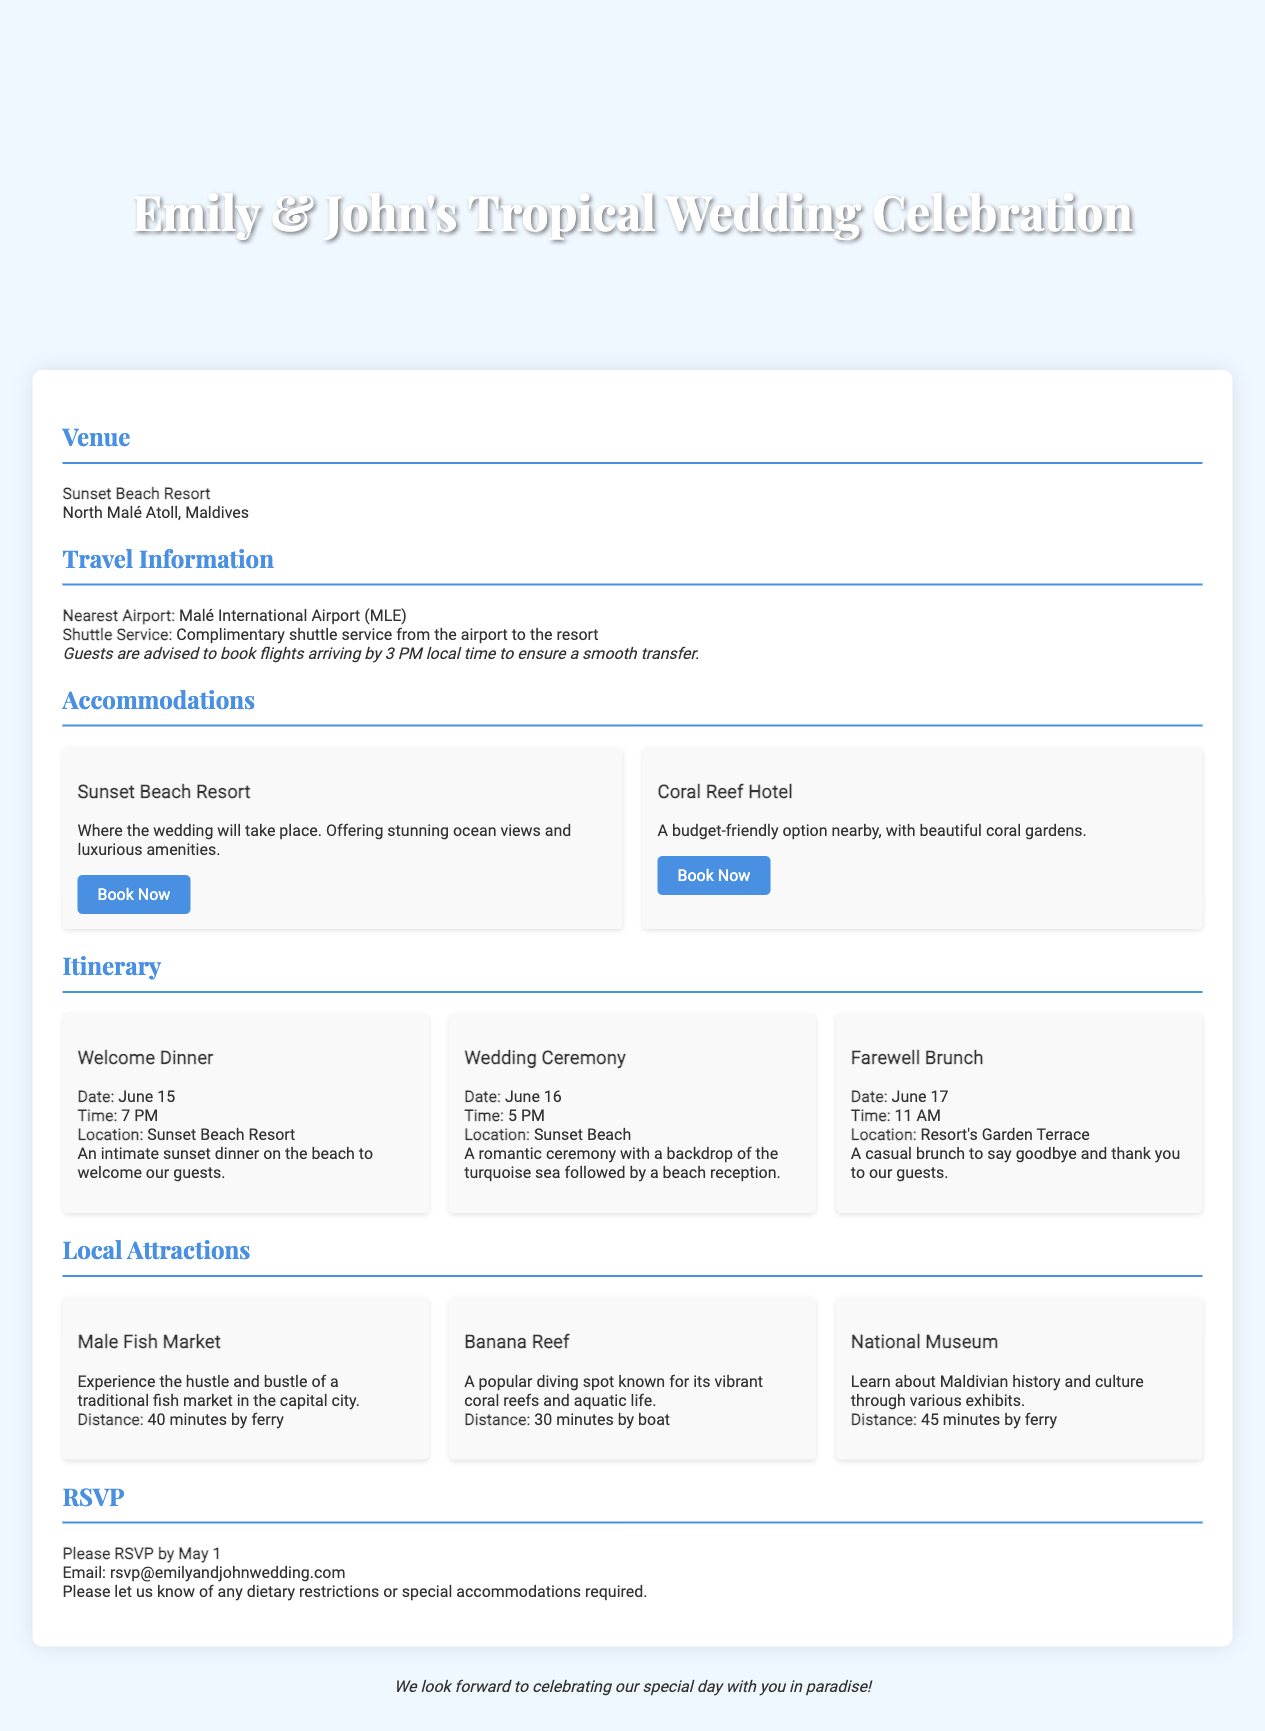What is the venue for the wedding? The venue is specified in the document as the location where the wedding will take place.
Answer: Sunset Beach Resort What is the date of the Wedding Ceremony? The date is mentioned under the itinerary section, specifically for the wedding event.
Answer: June 16 What time should guests book their flights for a smooth transfer? The document advises a specific flight arrival time to ensure a smooth transfer service.
Answer: 3 PM How far is Male Fish Market from the resort? The distance is provided under the local attractions section concerning travel time by ferry.
Answer: 40 minutes by ferry What is the color theme used for the section headers? The color of section headers is an important aspect of the design and layout within the document.
Answer: #4a90e2 What type of service is provided from the airport to the resort? This detail pertains to the travel information section of the invitation, describing the available service.
Answer: Complimentary shuttle service How should guests respond to the RSVP? The document specifies a method for guests to communicate their RSVP.
Answer: Email What is the main focus of the invitation? The invitation is tailored for a specific event, influencing its overall content and purpose.
Answer: Wedding celebration 